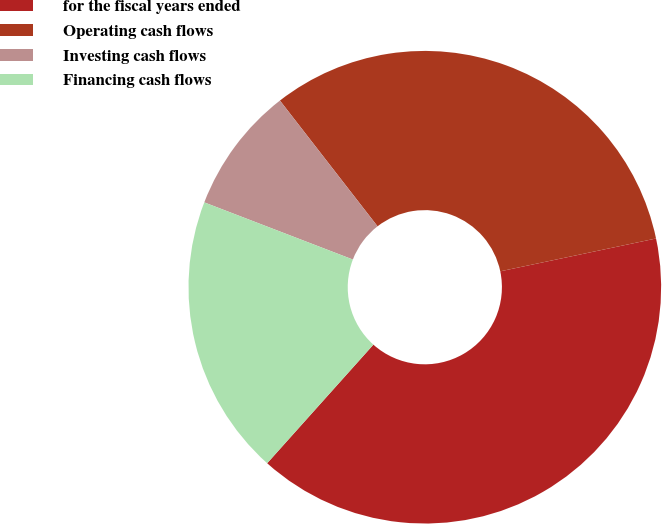<chart> <loc_0><loc_0><loc_500><loc_500><pie_chart><fcel>for the fiscal years ended<fcel>Operating cash flows<fcel>Investing cash flows<fcel>Financing cash flows<nl><fcel>39.93%<fcel>32.2%<fcel>8.65%<fcel>19.22%<nl></chart> 